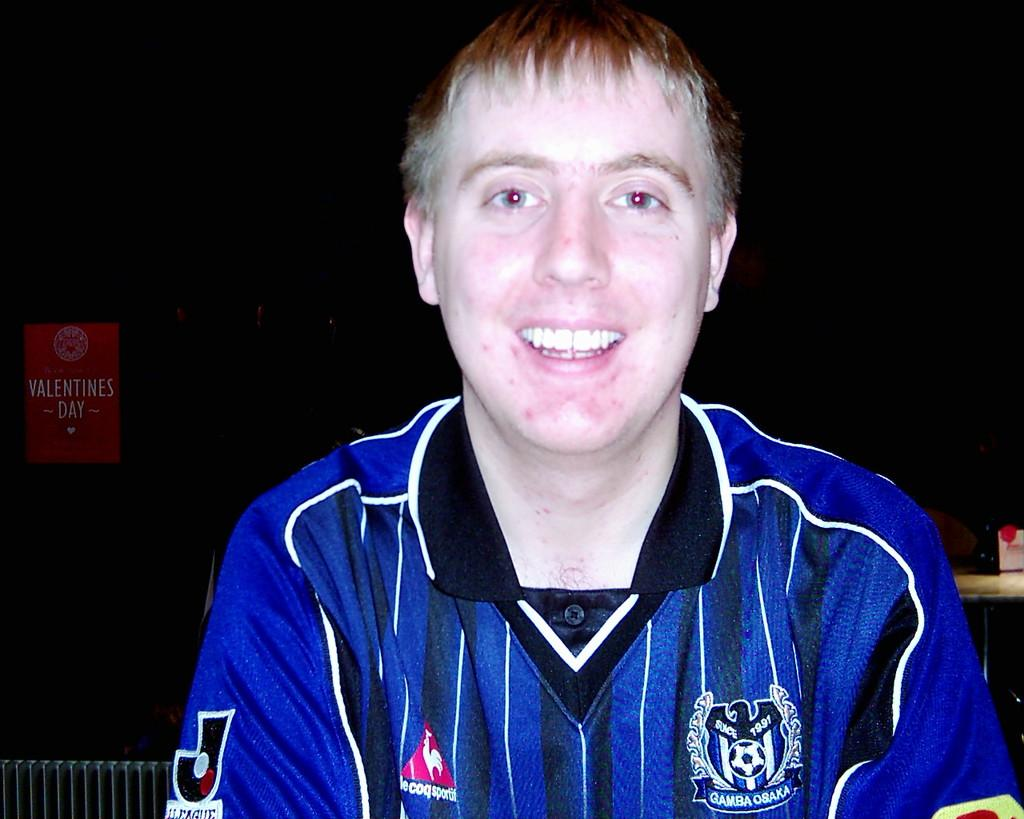Provide a one-sentence caption for the provided image. a man wearing a socker jersey labeled Gamba osaka. 